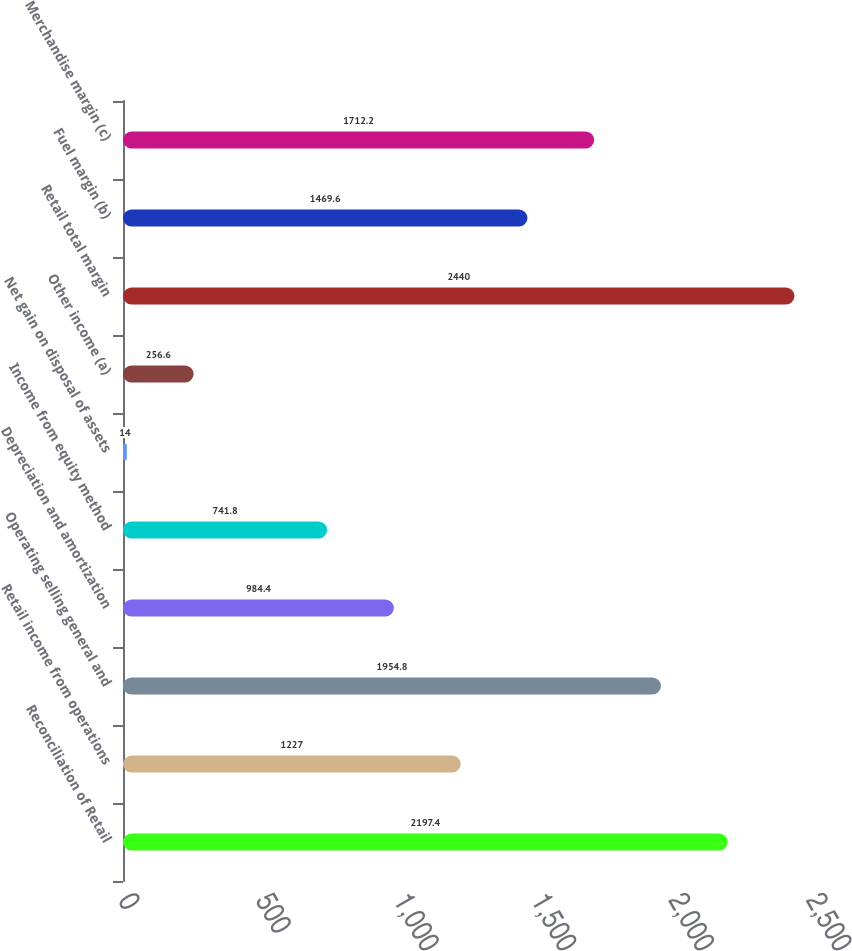<chart> <loc_0><loc_0><loc_500><loc_500><bar_chart><fcel>Reconciliation of Retail<fcel>Retail income from operations<fcel>Operating selling general and<fcel>Depreciation and amortization<fcel>Income from equity method<fcel>Net gain on disposal of assets<fcel>Other income (a)<fcel>Retail total margin<fcel>Fuel margin (b)<fcel>Merchandise margin (c)<nl><fcel>2197.4<fcel>1227<fcel>1954.8<fcel>984.4<fcel>741.8<fcel>14<fcel>256.6<fcel>2440<fcel>1469.6<fcel>1712.2<nl></chart> 